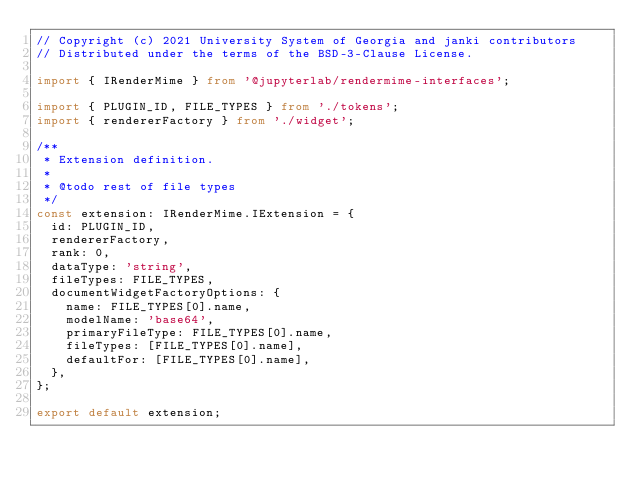<code> <loc_0><loc_0><loc_500><loc_500><_TypeScript_>// Copyright (c) 2021 University System of Georgia and janki contributors
// Distributed under the terms of the BSD-3-Clause License.

import { IRenderMime } from '@jupyterlab/rendermime-interfaces';

import { PLUGIN_ID, FILE_TYPES } from './tokens';
import { rendererFactory } from './widget';

/**
 * Extension definition.
 *
 * @todo rest of file types
 */
const extension: IRenderMime.IExtension = {
  id: PLUGIN_ID,
  rendererFactory,
  rank: 0,
  dataType: 'string',
  fileTypes: FILE_TYPES,
  documentWidgetFactoryOptions: {
    name: FILE_TYPES[0].name,
    modelName: 'base64',
    primaryFileType: FILE_TYPES[0].name,
    fileTypes: [FILE_TYPES[0].name],
    defaultFor: [FILE_TYPES[0].name],
  },
};

export default extension;
</code> 